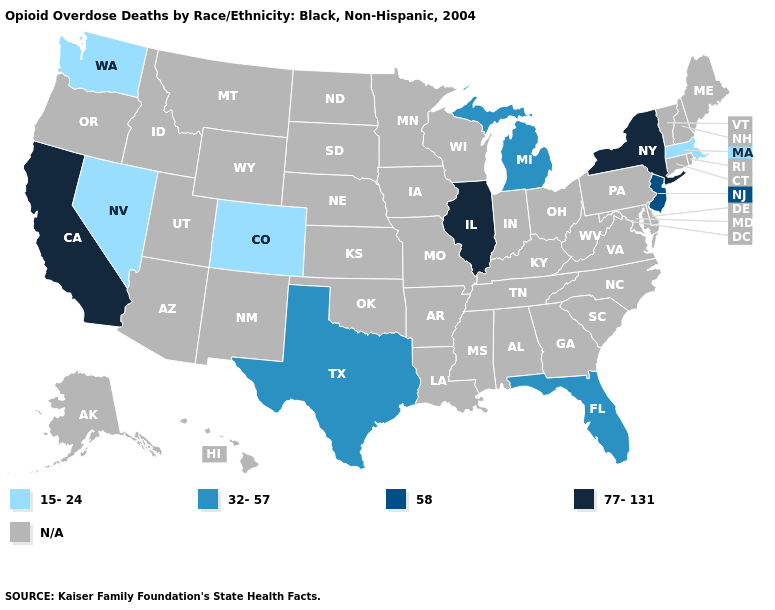Name the states that have a value in the range 58?
Concise answer only. New Jersey. What is the highest value in the USA?
Give a very brief answer. 77-131. What is the value of Pennsylvania?
Concise answer only. N/A. Name the states that have a value in the range 32-57?
Be succinct. Florida, Michigan, Texas. Name the states that have a value in the range N/A?
Short answer required. Alabama, Alaska, Arizona, Arkansas, Connecticut, Delaware, Georgia, Hawaii, Idaho, Indiana, Iowa, Kansas, Kentucky, Louisiana, Maine, Maryland, Minnesota, Mississippi, Missouri, Montana, Nebraska, New Hampshire, New Mexico, North Carolina, North Dakota, Ohio, Oklahoma, Oregon, Pennsylvania, Rhode Island, South Carolina, South Dakota, Tennessee, Utah, Vermont, Virginia, West Virginia, Wisconsin, Wyoming. Which states have the lowest value in the USA?
Be succinct. Colorado, Massachusetts, Nevada, Washington. What is the highest value in the MidWest ?
Answer briefly. 77-131. What is the lowest value in states that border Nebraska?
Be succinct. 15-24. Name the states that have a value in the range 32-57?
Keep it brief. Florida, Michigan, Texas. What is the value of California?
Keep it brief. 77-131. Which states have the lowest value in the USA?
Answer briefly. Colorado, Massachusetts, Nevada, Washington. Name the states that have a value in the range 32-57?
Give a very brief answer. Florida, Michigan, Texas. What is the value of Vermont?
Quick response, please. N/A. Name the states that have a value in the range 32-57?
Concise answer only. Florida, Michigan, Texas. 